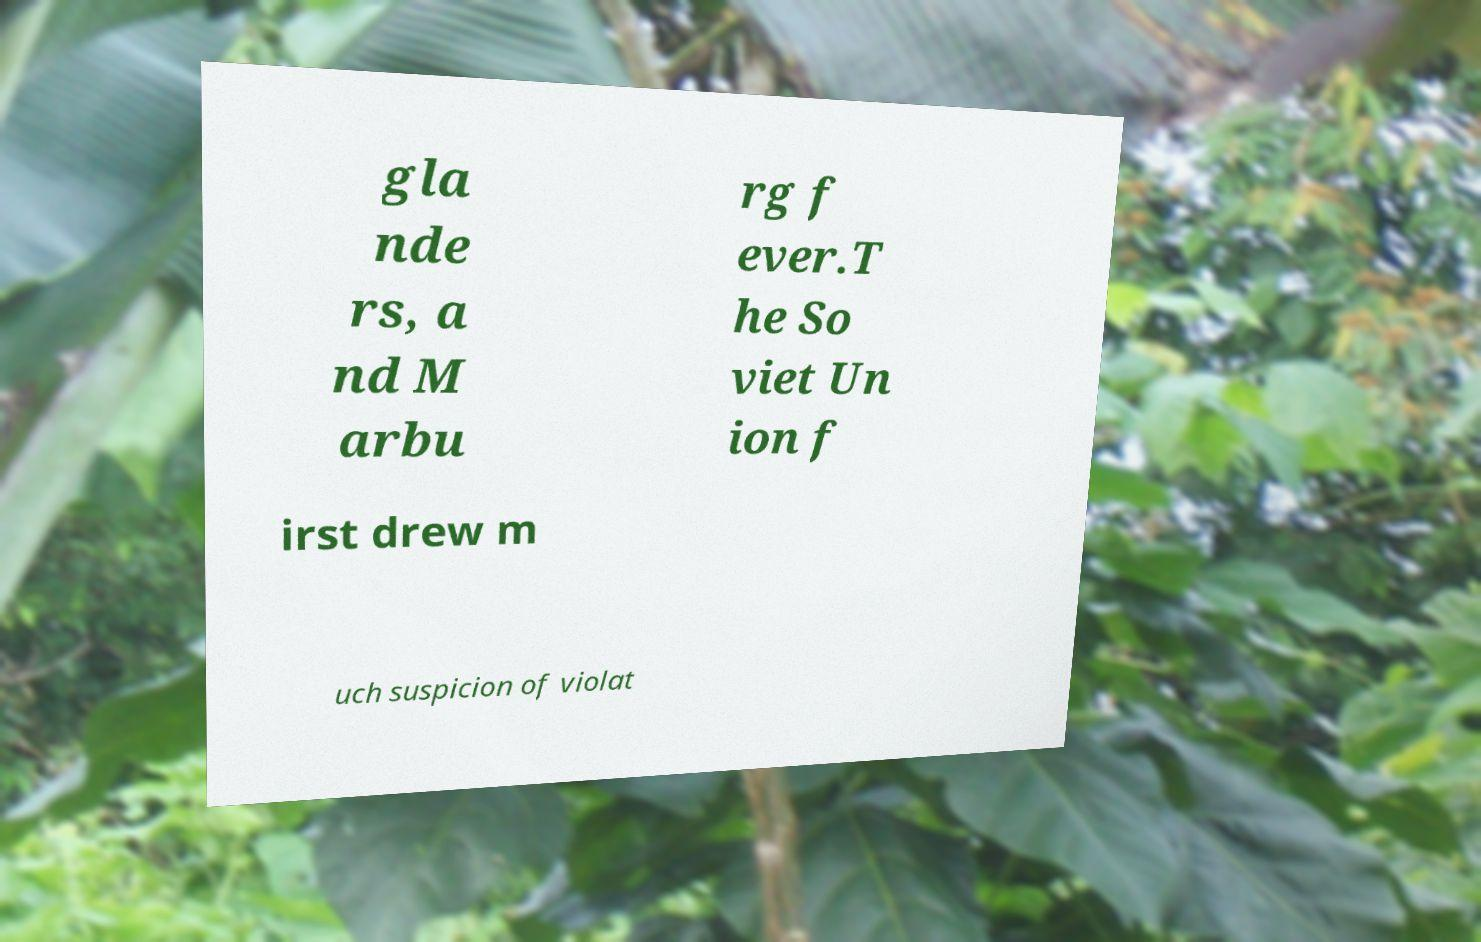For documentation purposes, I need the text within this image transcribed. Could you provide that? gla nde rs, a nd M arbu rg f ever.T he So viet Un ion f irst drew m uch suspicion of violat 